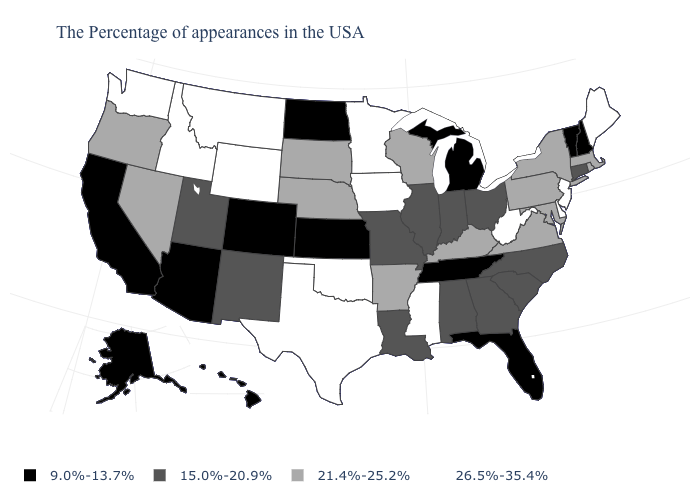What is the value of Idaho?
Short answer required. 26.5%-35.4%. What is the value of Washington?
Write a very short answer. 26.5%-35.4%. Name the states that have a value in the range 9.0%-13.7%?
Be succinct. New Hampshire, Vermont, Florida, Michigan, Tennessee, Kansas, North Dakota, Colorado, Arizona, California, Alaska, Hawaii. What is the value of New York?
Keep it brief. 21.4%-25.2%. Among the states that border West Virginia , which have the lowest value?
Answer briefly. Ohio. What is the lowest value in the West?
Concise answer only. 9.0%-13.7%. How many symbols are there in the legend?
Keep it brief. 4. Name the states that have a value in the range 21.4%-25.2%?
Give a very brief answer. Massachusetts, Rhode Island, New York, Maryland, Pennsylvania, Virginia, Kentucky, Wisconsin, Arkansas, Nebraska, South Dakota, Nevada, Oregon. Name the states that have a value in the range 15.0%-20.9%?
Write a very short answer. Connecticut, North Carolina, South Carolina, Ohio, Georgia, Indiana, Alabama, Illinois, Louisiana, Missouri, New Mexico, Utah. What is the lowest value in the South?
Answer briefly. 9.0%-13.7%. What is the lowest value in the West?
Give a very brief answer. 9.0%-13.7%. What is the lowest value in the USA?
Write a very short answer. 9.0%-13.7%. What is the value of California?
Write a very short answer. 9.0%-13.7%. Name the states that have a value in the range 21.4%-25.2%?
Answer briefly. Massachusetts, Rhode Island, New York, Maryland, Pennsylvania, Virginia, Kentucky, Wisconsin, Arkansas, Nebraska, South Dakota, Nevada, Oregon. What is the highest value in the West ?
Keep it brief. 26.5%-35.4%. 